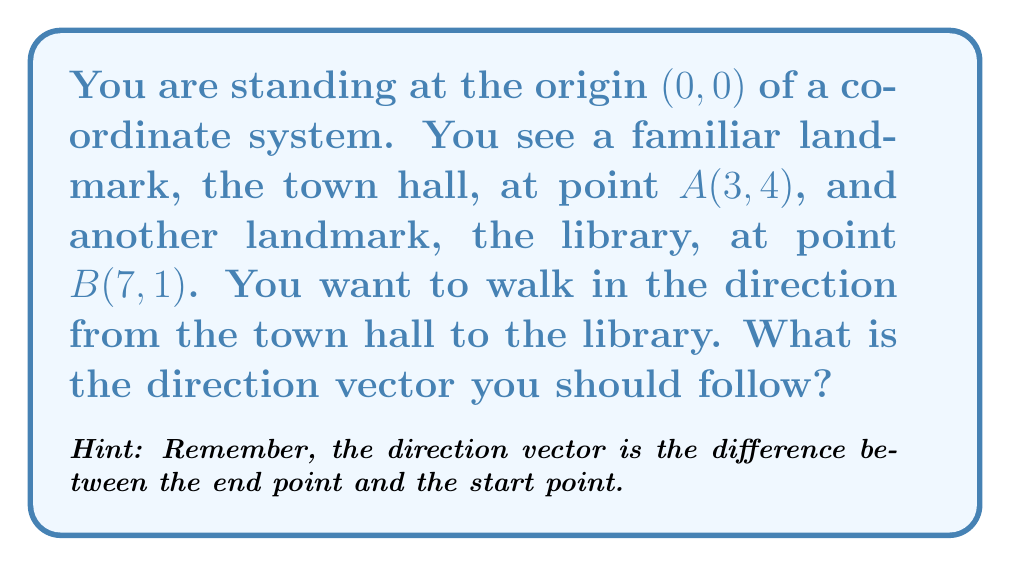What is the answer to this math problem? Let's approach this step-by-step:

1) First, recall that the direction vector from point A to point B is given by:
   $$\vec{v} = B - A$$

2) We have:
   Point A (town hall): (3, 4)
   Point B (library): (7, 1)

3) To find the direction vector, we subtract the coordinates of A from B:
   $$\vec{v} = (7 - 3, 1 - 4)$$

4) Simplifying:
   $$\vec{v} = (4, -3)$$

5) This vector (4, -3) represents the direction and magnitude of the path from the town hall to the library.

6) To visualize this, imagine moving 4 units to the right (positive x-direction) and 3 units down (negative y-direction) from the town hall to reach the library.

Remember: The direction vector tells you which way to go and how far, starting from any point. In this case, it's telling you to go 4 units east and 3 units south to get from the town hall to the library.
Answer: The direction vector from the town hall to the library is $\vec{v} = (4, -3)$. 